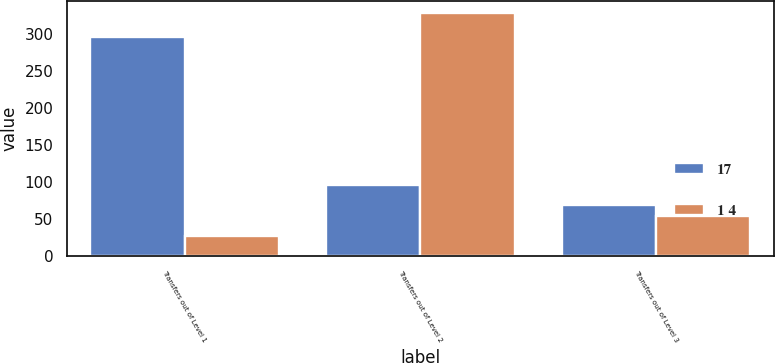Convert chart to OTSL. <chart><loc_0><loc_0><loc_500><loc_500><stacked_bar_chart><ecel><fcel>Transfers out of Level 1<fcel>Transfers out of Level 2<fcel>Transfers out of Level 3<nl><fcel>17<fcel>297<fcel>97<fcel>69<nl><fcel>1 4<fcel>28<fcel>329<fcel>55<nl></chart> 